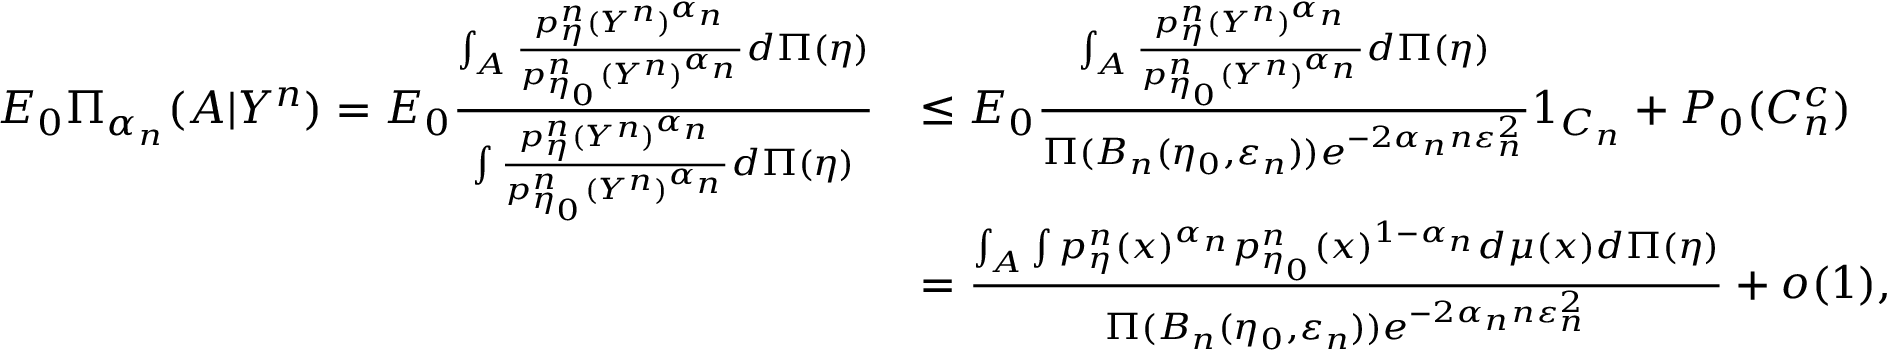<formula> <loc_0><loc_0><loc_500><loc_500>\begin{array} { r l } { E _ { 0 } \Pi _ { \alpha _ { n } } ( A | Y ^ { n } ) = E _ { 0 } \frac { \int _ { A } \frac { p _ { \eta } ^ { n } ( Y ^ { n } ) ^ { \alpha _ { n } } } { p _ { \eta _ { 0 } } ^ { n } ( Y ^ { n } ) ^ { \alpha _ { n } } } d \Pi ( \eta ) } { \int \frac { p _ { \eta } ^ { n } ( Y ^ { n } ) ^ { \alpha _ { n } } } { p _ { \eta _ { 0 } } ^ { n } ( Y ^ { n } ) ^ { \alpha _ { n } } } d \Pi ( \eta ) } } & { \leq E _ { 0 } \frac { \int _ { A } \frac { p _ { \eta } ^ { n } ( Y ^ { n } ) ^ { \alpha _ { n } } } { p _ { \eta _ { 0 } } ^ { n } ( Y ^ { n } ) ^ { \alpha _ { n } } } d \Pi ( \eta ) } { \Pi ( B _ { n } ( \eta _ { 0 } , \varepsilon _ { n } ) ) e ^ { - 2 { \alpha _ { n } } n \varepsilon _ { n } ^ { 2 } } } 1 _ { C _ { n } } + P _ { 0 } ( C _ { n } ^ { c } ) } \\ & { = \frac { \int _ { A } \int p _ { \eta } ^ { n } ( x ) ^ { \alpha _ { n } } p _ { \eta _ { 0 } } ^ { n } ( x ) ^ { 1 - \alpha _ { n } } d \mu ( x ) d \Pi ( \eta ) } { \Pi ( B _ { n } ( \eta _ { 0 } , \varepsilon _ { n } ) ) e ^ { - 2 { \alpha _ { n } } n \varepsilon _ { n } ^ { 2 } } } + o ( 1 ) , } \end{array}</formula> 